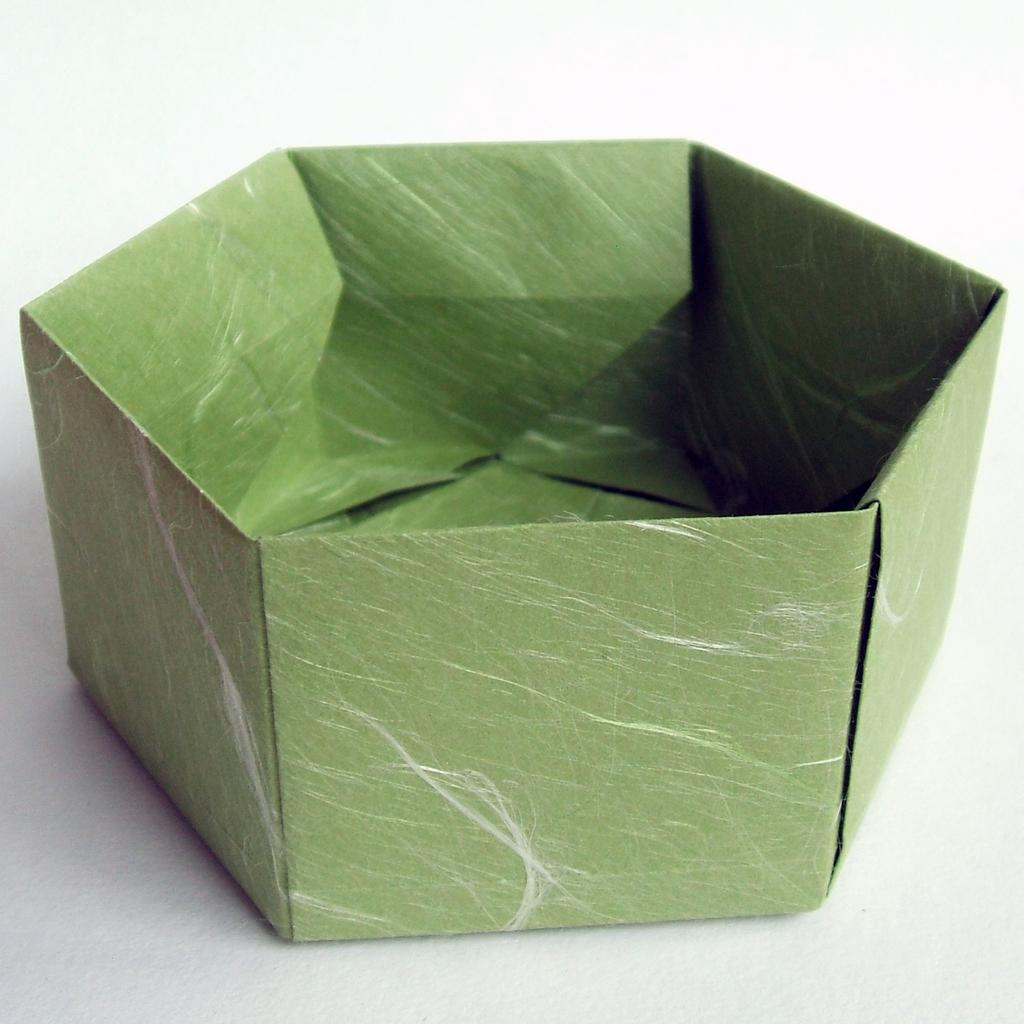What is the main subject in the image? There is a craft in the image. What is the color of the surface on which the craft is placed? The craft is on a white surface. What type of ship can be seen sailing in the background of the image? There is no ship visible in the image; it only features a craft on a white surface. What is the zinc content of the craft in the image? There is no information about the zinc content of the craft in the image, as it does not mention any materials or elements. 